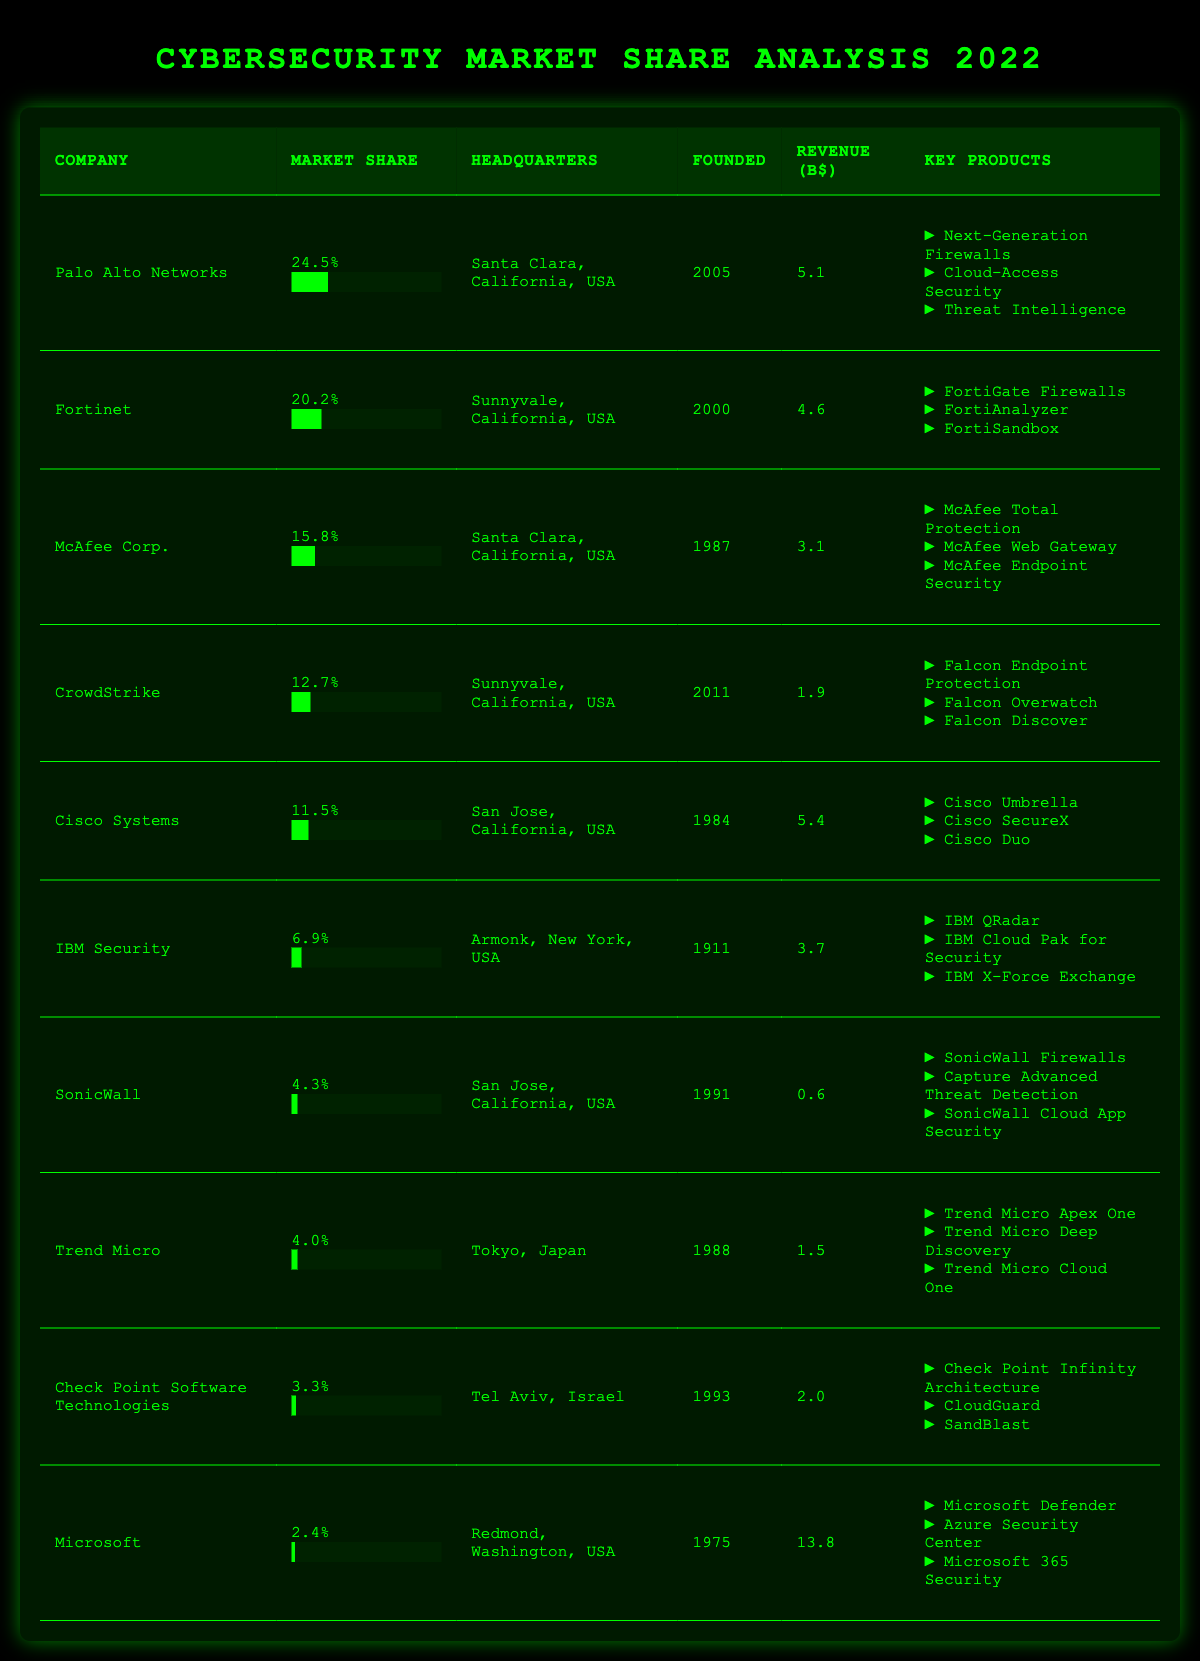What company has the highest market share in 2022? By looking at the "Market Share" column, Palo Alto Networks has the highest percentage at 24.5%.
Answer: Palo Alto Networks Which company is headquartered in Santa Clara, California? There are two companies: Palo Alto Networks and McAfee Corp., both listed under Santa Clara, California, in the "Headquarters" column.
Answer: Palo Alto Networks and McAfee Corp What is the total market share percentage of the top three companies? Adding the market shares of the top three companies: 24.5% (Palo Alto Networks) + 20.2% (Fortinet) + 15.8% (McAfee Corp.) = 60.5%.
Answer: 60.5% Which company generated the highest revenue in billions? The "Revenue" column shows that Microsoft generated the highest revenue at 13.8 billion dollars.
Answer: Microsoft What percentage of the market share does IBM Security hold? Referring to the table, IBM Security holds a market share of 6.9%.
Answer: 6.9% How many companies were founded after 2000? The companies founded after 2000 are Palo Alto Networks (2005), Fortinet (2000), and CrowdStrike (2011), totaling three companies.
Answer: 3 Is the market share of Trend Micro higher than that of Check Point Software Technologies? Trend Micro has a market share of 4.0%, which is indeed higher than Check Point Software Technologies, which has 3.3%.
Answer: Yes What is the average market share of the companies listed? To find the average, sum the market shares (24.5 + 20.2 + 15.8 + 12.7 + 11.5 + 6.9 + 4.3 + 4.0 + 3.3 + 2.4) = 106.6 and divide by the total number of companies (10): 106.6 / 10 = 10.66%.
Answer: 10.66% Which company makes "Falcon Endpoint Protection"? Referring to the "Key Products" column, CrowdStrike makes "Falcon Endpoint Protection."
Answer: CrowdStrike What is the difference in market share percentage between Cisco Systems and SonicWall? Cisco Systems has 11.5% and SonicWall has 4.3%. The difference is 11.5 - 4.3 = 7.2%.
Answer: 7.2% 